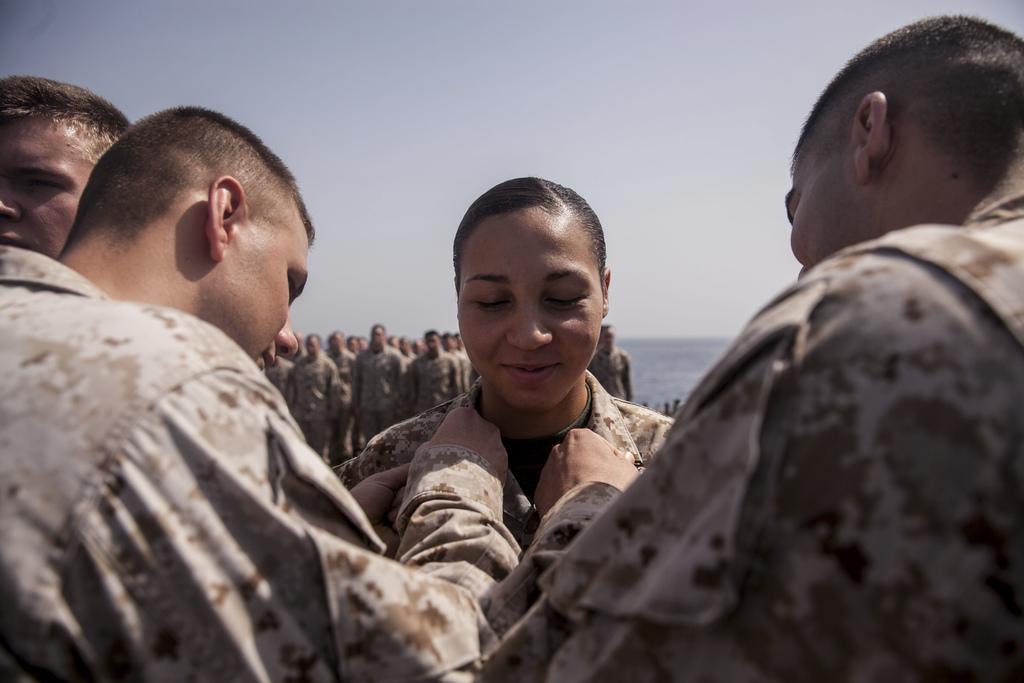Please provide a concise description of this image. In this image, we can see some people standing, in the background there are some people standing in a queue and at the top there is a sky. 